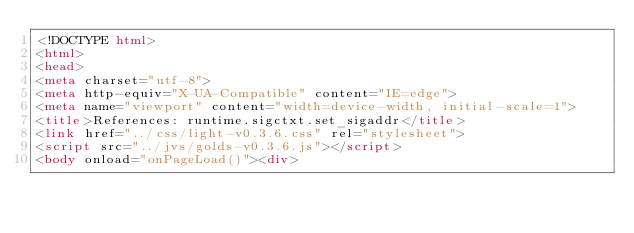Convert code to text. <code><loc_0><loc_0><loc_500><loc_500><_HTML_><!DOCTYPE html>
<html>
<head>
<meta charset="utf-8">
<meta http-equiv="X-UA-Compatible" content="IE=edge">
<meta name="viewport" content="width=device-width, initial-scale=1">
<title>References: runtime.sigctxt.set_sigaddr</title>
<link href="../css/light-v0.3.6.css" rel="stylesheet">
<script src="../jvs/golds-v0.3.6.js"></script>
<body onload="onPageLoad()"><div>
</code> 